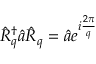Convert formula to latex. <formula><loc_0><loc_0><loc_500><loc_500>\hat { R } _ { q } ^ { \dagger } \hat { a } \hat { R } _ { q } = \hat { a } e ^ { i \frac { 2 \pi } { q } }</formula> 